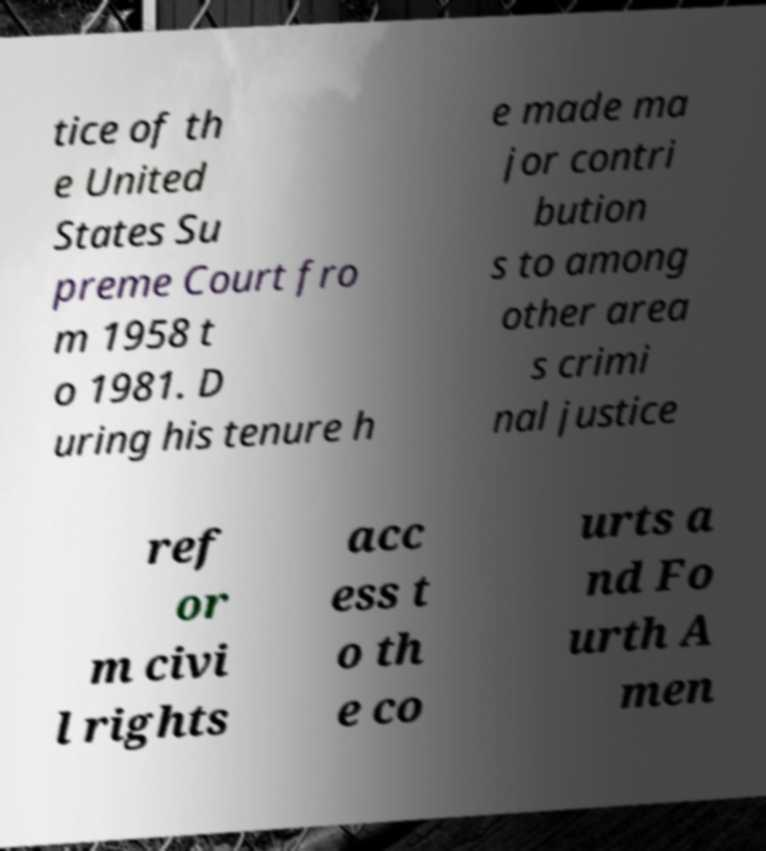What messages or text are displayed in this image? I need them in a readable, typed format. tice of th e United States Su preme Court fro m 1958 t o 1981. D uring his tenure h e made ma jor contri bution s to among other area s crimi nal justice ref or m civi l rights acc ess t o th e co urts a nd Fo urth A men 